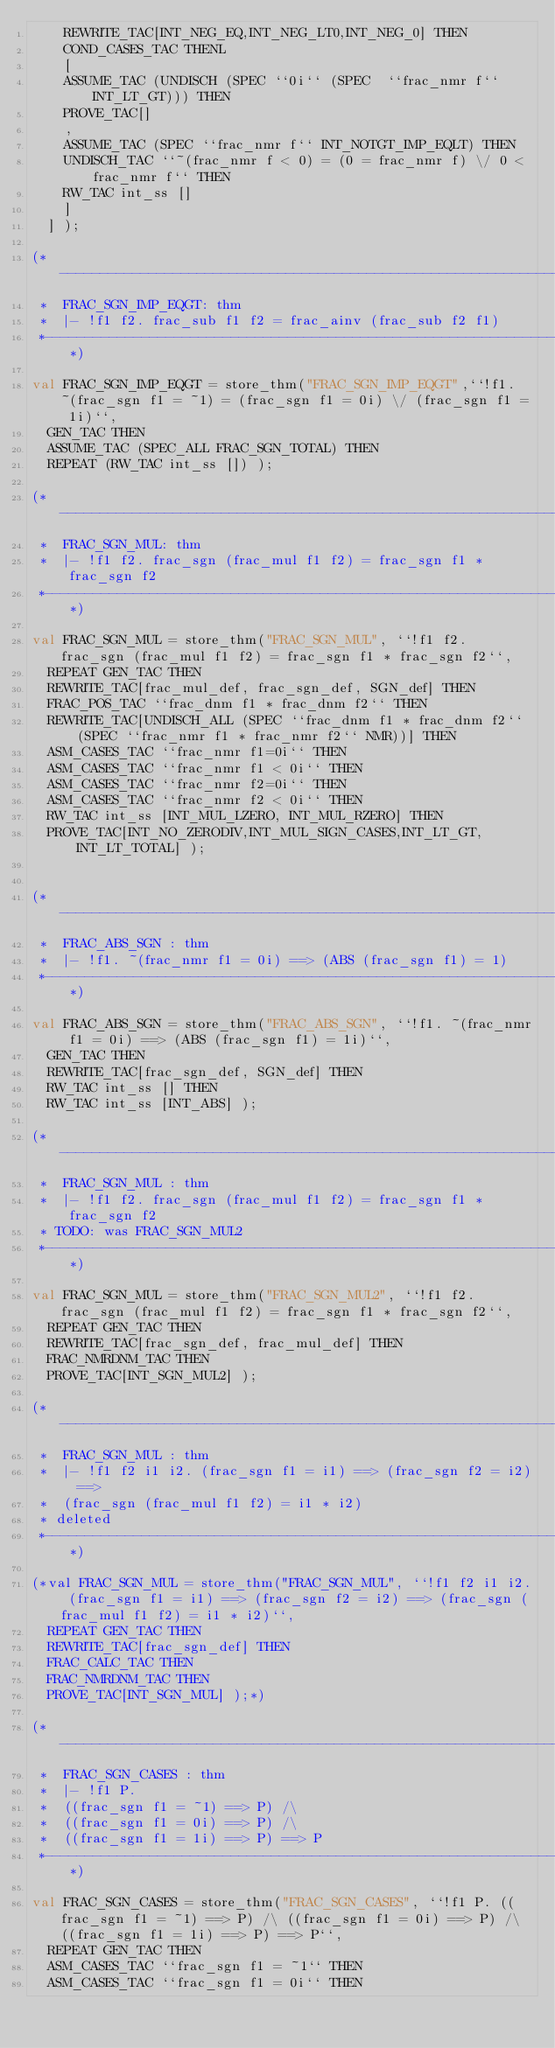<code> <loc_0><loc_0><loc_500><loc_500><_SML_>		REWRITE_TAC[INT_NEG_EQ,INT_NEG_LT0,INT_NEG_0] THEN
		COND_CASES_TAC THENL
		[
		ASSUME_TAC (UNDISCH (SPEC ``0i`` (SPEC  ``frac_nmr f`` INT_LT_GT))) THEN
		PROVE_TAC[]
		,
		ASSUME_TAC (SPEC ``frac_nmr f`` INT_NOTGT_IMP_EQLT) THEN
		UNDISCH_TAC ``~(frac_nmr f < 0) = (0 = frac_nmr f) \/ 0 < frac_nmr f`` THEN
		RW_TAC int_ss []
		]
	] );

(*--------------------------------------------------------------------------
 *  FRAC_SGN_IMP_EQGT: thm
 *  |- !f1 f2. frac_sub f1 f2 = frac_ainv (frac_sub f2 f1)
 *--------------------------------------------------------------------------*)

val FRAC_SGN_IMP_EQGT = store_thm("FRAC_SGN_IMP_EQGT",``!f1. ~(frac_sgn f1 = ~1) = (frac_sgn f1 = 0i) \/ (frac_sgn f1 = 1i)``,
	GEN_TAC THEN
	ASSUME_TAC (SPEC_ALL FRAC_SGN_TOTAL) THEN
	REPEAT (RW_TAC int_ss []) );

(*--------------------------------------------------------------------------
 *  FRAC_SGN_MUL: thm
 *  |- !f1 f2. frac_sgn (frac_mul f1 f2) = frac_sgn f1 * frac_sgn f2
 *--------------------------------------------------------------------------*)

val FRAC_SGN_MUL = store_thm("FRAC_SGN_MUL", ``!f1 f2. frac_sgn (frac_mul f1 f2) = frac_sgn f1 * frac_sgn f2``,
	REPEAT GEN_TAC THEN
	REWRITE_TAC[frac_mul_def, frac_sgn_def, SGN_def] THEN
	FRAC_POS_TAC ``frac_dnm f1 * frac_dnm f2`` THEN
	REWRITE_TAC[UNDISCH_ALL (SPEC ``frac_dnm f1 * frac_dnm f2`` (SPEC ``frac_nmr f1 * frac_nmr f2`` NMR))] THEN
	ASM_CASES_TAC ``frac_nmr f1=0i`` THEN
	ASM_CASES_TAC ``frac_nmr f1 < 0i`` THEN
	ASM_CASES_TAC ``frac_nmr f2=0i`` THEN
	ASM_CASES_TAC ``frac_nmr f2 < 0i`` THEN
	RW_TAC int_ss [INT_MUL_LZERO, INT_MUL_RZERO] THEN
	PROVE_TAC[INT_NO_ZERODIV,INT_MUL_SIGN_CASES,INT_LT_GT,INT_LT_TOTAL] );


(*--------------------------------------------------------------------------
 *  FRAC_ABS_SGN : thm
 *  |- !f1. ~(frac_nmr f1 = 0i) ==> (ABS (frac_sgn f1) = 1)
 *--------------------------------------------------------------------------*)

val FRAC_ABS_SGN = store_thm("FRAC_ABS_SGN", ``!f1. ~(frac_nmr f1 = 0i) ==> (ABS (frac_sgn f1) = 1i)``,
	GEN_TAC THEN
	REWRITE_TAC[frac_sgn_def, SGN_def] THEN
	RW_TAC int_ss [] THEN
	RW_TAC int_ss [INT_ABS] );

(*--------------------------------------------------------------------------
 *  FRAC_SGN_MUL : thm
 *  |- !f1 f2. frac_sgn (frac_mul f1 f2) = frac_sgn f1 * frac_sgn f2
 * TODO: was FRAC_SGN_MUL2
 *--------------------------------------------------------------------------*)

val FRAC_SGN_MUL = store_thm("FRAC_SGN_MUL2", ``!f1 f2. frac_sgn (frac_mul f1 f2) = frac_sgn f1 * frac_sgn f2``,
	REPEAT GEN_TAC THEN
	REWRITE_TAC[frac_sgn_def, frac_mul_def] THEN
	FRAC_NMRDNM_TAC THEN
	PROVE_TAC[INT_SGN_MUL2] );

(*--------------------------------------------------------------------------
 *  FRAC_SGN_MUL : thm
 *  |- !f1 f2 i1 i2. (frac_sgn f1 = i1) ==> (frac_sgn f2 = i2) ==>
 *	(frac_sgn (frac_mul f1 f2) = i1 * i2)
 * deleted
 *--------------------------------------------------------------------------*)

(*val FRAC_SGN_MUL = store_thm("FRAC_SGN_MUL", ``!f1 f2 i1 i2. (frac_sgn f1 = i1) ==> (frac_sgn f2 = i2) ==> (frac_sgn (frac_mul f1 f2) = i1 * i2)``,
	REPEAT GEN_TAC THEN
	REWRITE_TAC[frac_sgn_def] THEN
	FRAC_CALC_TAC THEN
	FRAC_NMRDNM_TAC THEN
	PROVE_TAC[INT_SGN_MUL] );*)

(*--------------------------------------------------------------------------
 *  FRAC_SGN_CASES : thm
 *  |- !f1 P.
 *	((frac_sgn f1 = ~1) ==> P) /\
 *	((frac_sgn f1 = 0i) ==> P) /\
 *	((frac_sgn f1 = 1i) ==> P) ==> P
 *--------------------------------------------------------------------------*)

val FRAC_SGN_CASES = store_thm("FRAC_SGN_CASES", ``!f1 P. ((frac_sgn f1 = ~1) ==> P) /\ ((frac_sgn f1 = 0i) ==> P) /\ ((frac_sgn f1 = 1i) ==> P) ==> P``,
	REPEAT GEN_TAC THEN
	ASM_CASES_TAC ``frac_sgn f1 = ~1`` THEN
	ASM_CASES_TAC ``frac_sgn f1 = 0i`` THEN</code> 